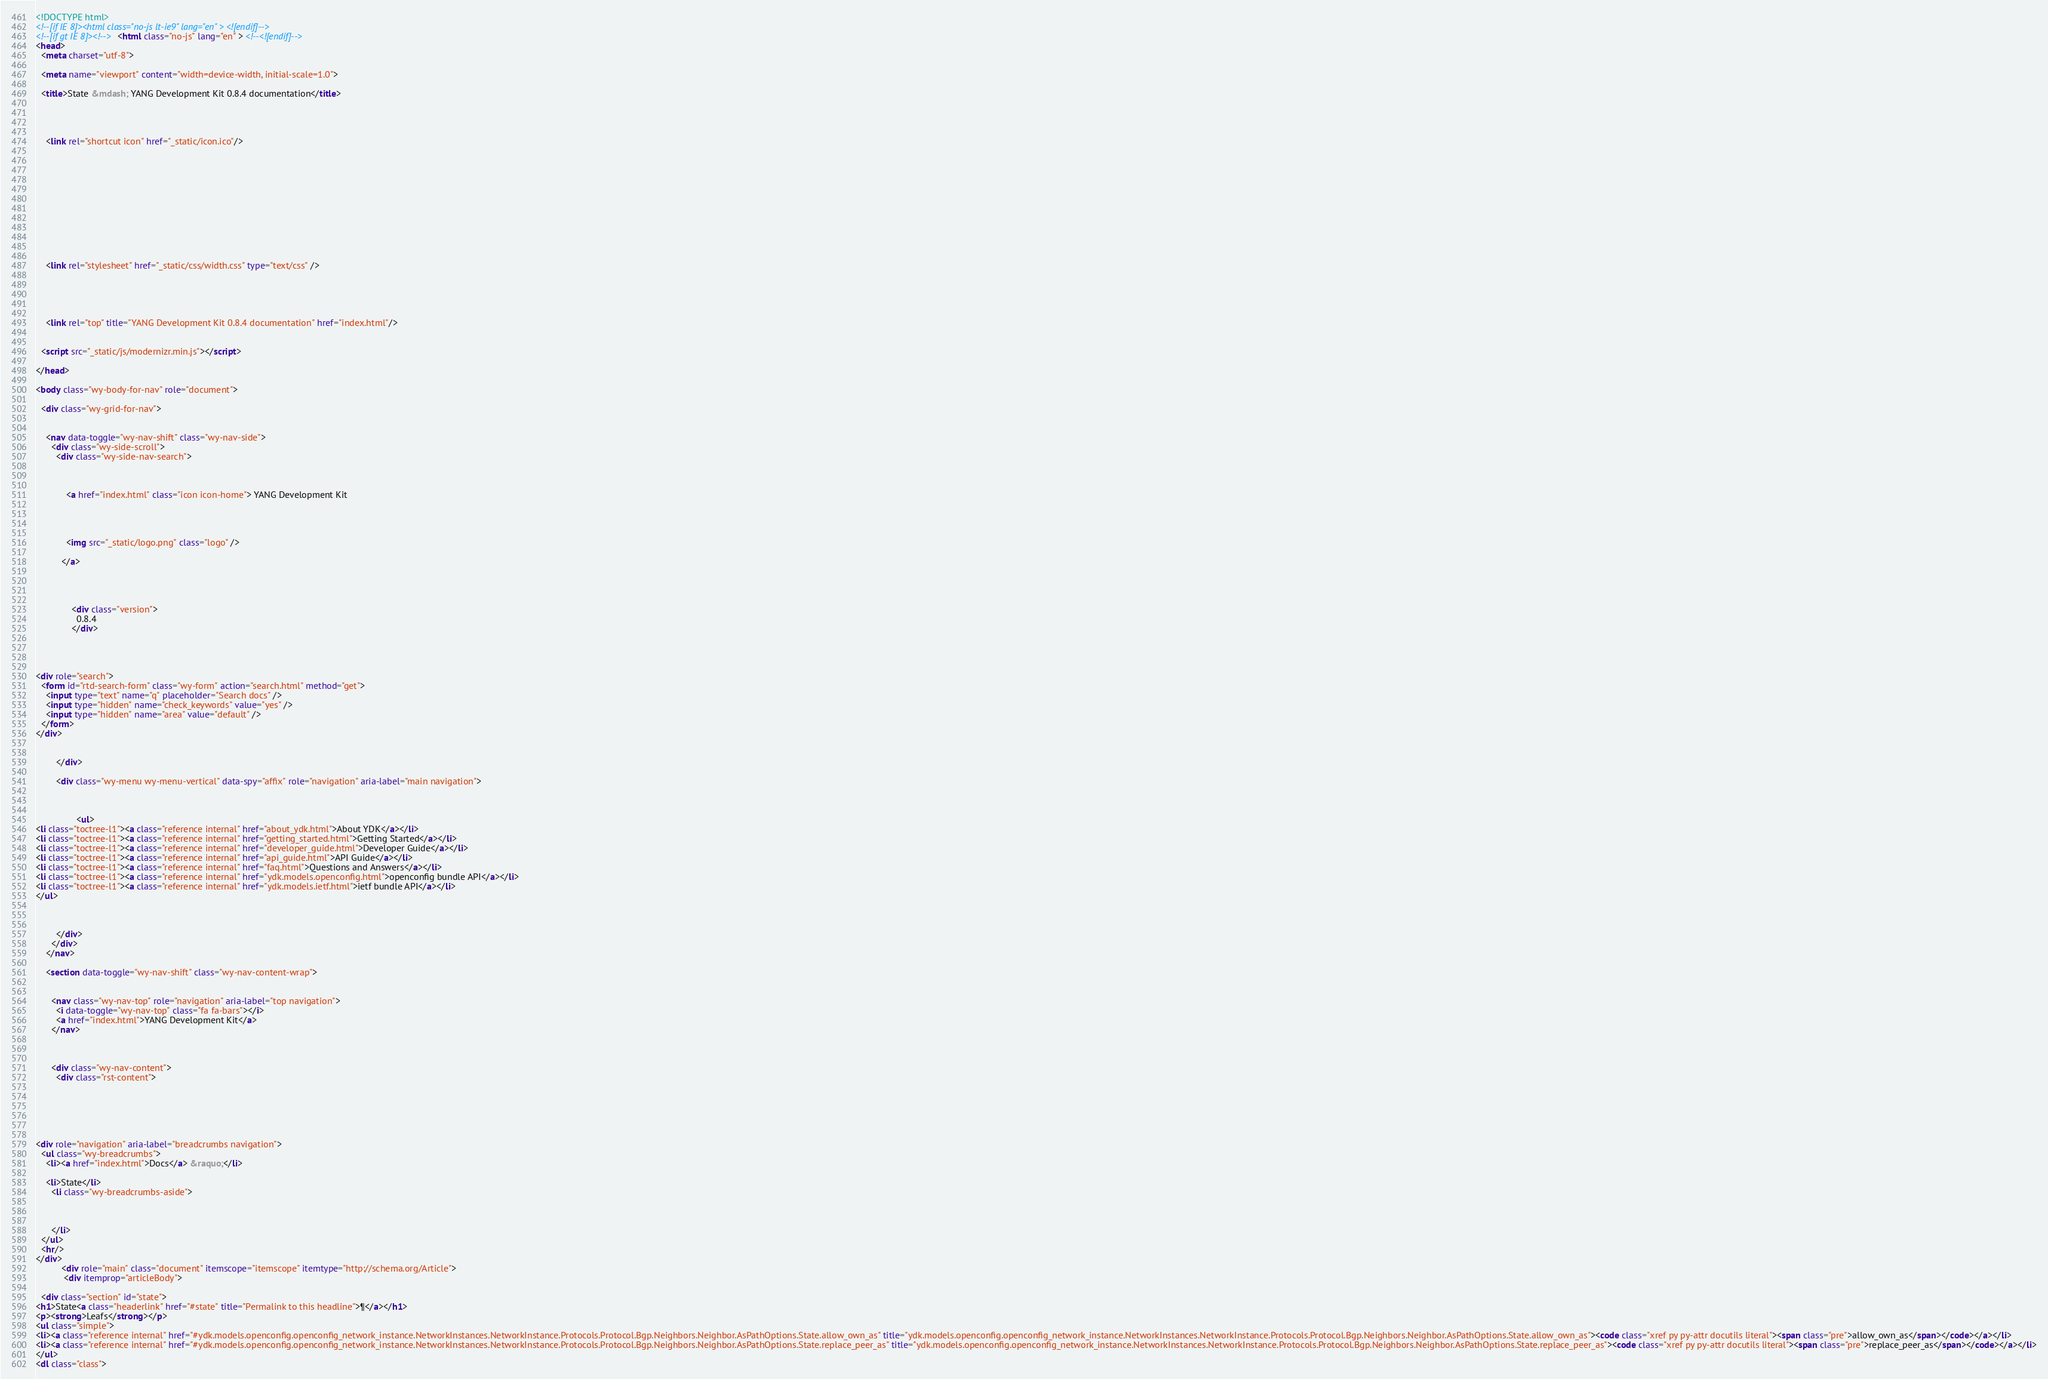<code> <loc_0><loc_0><loc_500><loc_500><_HTML_>

<!DOCTYPE html>
<!--[if IE 8]><html class="no-js lt-ie9" lang="en" > <![endif]-->
<!--[if gt IE 8]><!--> <html class="no-js" lang="en" > <!--<![endif]-->
<head>
  <meta charset="utf-8">
  
  <meta name="viewport" content="width=device-width, initial-scale=1.0">
  
  <title>State &mdash; YANG Development Kit 0.8.4 documentation</title>
  

  
  
    <link rel="shortcut icon" href="_static/icon.ico"/>
  

  

  
  
    

  

  
  
    <link rel="stylesheet" href="_static/css/width.css" type="text/css" />
  

  

  
    <link rel="top" title="YANG Development Kit 0.8.4 documentation" href="index.html"/> 

  
  <script src="_static/js/modernizr.min.js"></script>

</head>

<body class="wy-body-for-nav" role="document">

  <div class="wy-grid-for-nav">

    
    <nav data-toggle="wy-nav-shift" class="wy-nav-side">
      <div class="wy-side-scroll">
        <div class="wy-side-nav-search">
          

          
            <a href="index.html" class="icon icon-home"> YANG Development Kit
          

          
            
            <img src="_static/logo.png" class="logo" />
          
          </a>

          
            
            
              <div class="version">
                0.8.4
              </div>
            
          

          
<div role="search">
  <form id="rtd-search-form" class="wy-form" action="search.html" method="get">
    <input type="text" name="q" placeholder="Search docs" />
    <input type="hidden" name="check_keywords" value="yes" />
    <input type="hidden" name="area" value="default" />
  </form>
</div>

          
        </div>

        <div class="wy-menu wy-menu-vertical" data-spy="affix" role="navigation" aria-label="main navigation">
          
            
            
                <ul>
<li class="toctree-l1"><a class="reference internal" href="about_ydk.html">About YDK</a></li>
<li class="toctree-l1"><a class="reference internal" href="getting_started.html">Getting Started</a></li>
<li class="toctree-l1"><a class="reference internal" href="developer_guide.html">Developer Guide</a></li>
<li class="toctree-l1"><a class="reference internal" href="api_guide.html">API Guide</a></li>
<li class="toctree-l1"><a class="reference internal" href="faq.html">Questions and Answers</a></li>
<li class="toctree-l1"><a class="reference internal" href="ydk.models.openconfig.html">openconfig bundle API</a></li>
<li class="toctree-l1"><a class="reference internal" href="ydk.models.ietf.html">ietf bundle API</a></li>
</ul>

            
          
        </div>
      </div>
    </nav>

    <section data-toggle="wy-nav-shift" class="wy-nav-content-wrap">

      
      <nav class="wy-nav-top" role="navigation" aria-label="top navigation">
        <i data-toggle="wy-nav-top" class="fa fa-bars"></i>
        <a href="index.html">YANG Development Kit</a>
      </nav>


      
      <div class="wy-nav-content">
        <div class="rst-content">
          

 



<div role="navigation" aria-label="breadcrumbs navigation">
  <ul class="wy-breadcrumbs">
    <li><a href="index.html">Docs</a> &raquo;</li>
      
    <li>State</li>
      <li class="wy-breadcrumbs-aside">
        
          
        
      </li>
  </ul>
  <hr/>
</div>
          <div role="main" class="document" itemscope="itemscope" itemtype="http://schema.org/Article">
           <div itemprop="articleBody">
            
  <div class="section" id="state">
<h1>State<a class="headerlink" href="#state" title="Permalink to this headline">¶</a></h1>
<p><strong>Leafs</strong></p>
<ul class="simple">
<li><a class="reference internal" href="#ydk.models.openconfig.openconfig_network_instance.NetworkInstances.NetworkInstance.Protocols.Protocol.Bgp.Neighbors.Neighbor.AsPathOptions.State.allow_own_as" title="ydk.models.openconfig.openconfig_network_instance.NetworkInstances.NetworkInstance.Protocols.Protocol.Bgp.Neighbors.Neighbor.AsPathOptions.State.allow_own_as"><code class="xref py py-attr docutils literal"><span class="pre">allow_own_as</span></code></a></li>
<li><a class="reference internal" href="#ydk.models.openconfig.openconfig_network_instance.NetworkInstances.NetworkInstance.Protocols.Protocol.Bgp.Neighbors.Neighbor.AsPathOptions.State.replace_peer_as" title="ydk.models.openconfig.openconfig_network_instance.NetworkInstances.NetworkInstance.Protocols.Protocol.Bgp.Neighbors.Neighbor.AsPathOptions.State.replace_peer_as"><code class="xref py py-attr docutils literal"><span class="pre">replace_peer_as</span></code></a></li>
</ul>
<dl class="class"></code> 